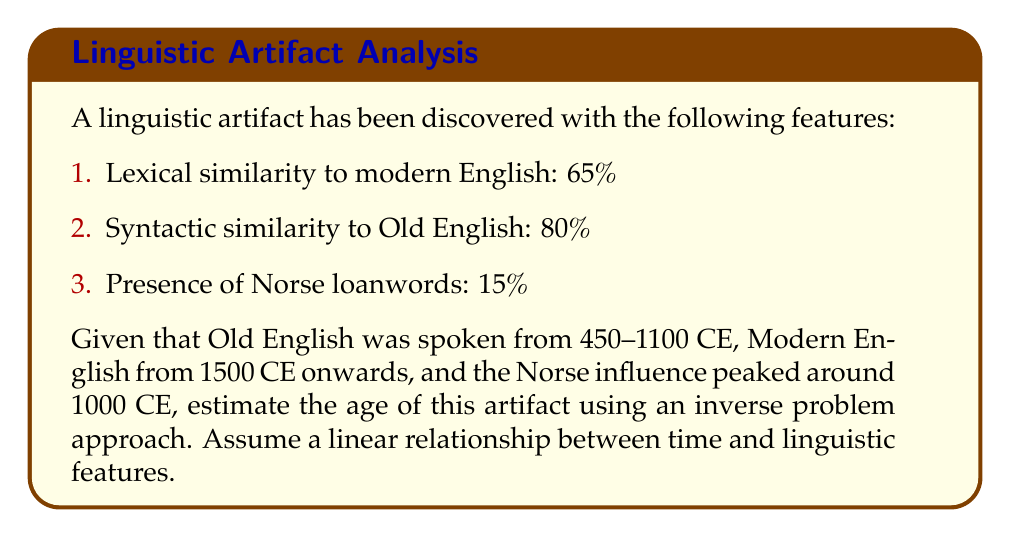Teach me how to tackle this problem. 1. Define variables:
   Let $t$ = years before present (BP)
   Let $x_1$ = lexical similarity to modern English (%)
   Let $x_2$ = syntactic similarity to Old English (%)
   Let $x_3$ = presence of Norse loanwords (%)

2. Establish time points:
   Modern English: 0 BP (present)
   Old English: 1570 BP (midpoint of 450-1100 CE)
   Peak Norse influence: 1020 BP

3. Set up linear equations:
   $x_1 = 100 - 0.0223t$ (assuming 100% similarity at present, 65% at 1570 BP)
   $x_2 = 100 - 0.0127t$ (assuming 100% similarity at 1570 BP, 80% for artifact)
   $x_3 = 15 - 0.0147|t - 1020|$ (assuming 15% peak at 1020 BP, decreasing linearly in both directions)

4. Substitute known values:
   $65 = 100 - 0.0223t$
   $80 = 100 - 0.0127t$
   $15 = 15 - 0.0147|t - 1020|$

5. Solve equations:
   From equation 1: $t = 1569.5$
   From equation 2: $t = 1574.8$
   Equation 3 is satisfied when $t = 1020$

6. Take the average of the three estimates:
   $t = (1569.5 + 1574.8 + 1020) / 3 = 1388.1$

7. Convert to CE:
   2023 (current year) - 1388 = 635 CE
Answer: 635 CE 